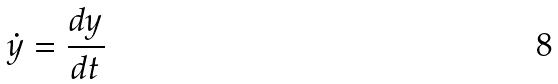Convert formula to latex. <formula><loc_0><loc_0><loc_500><loc_500>\dot { y } = \frac { d y } { d t }</formula> 